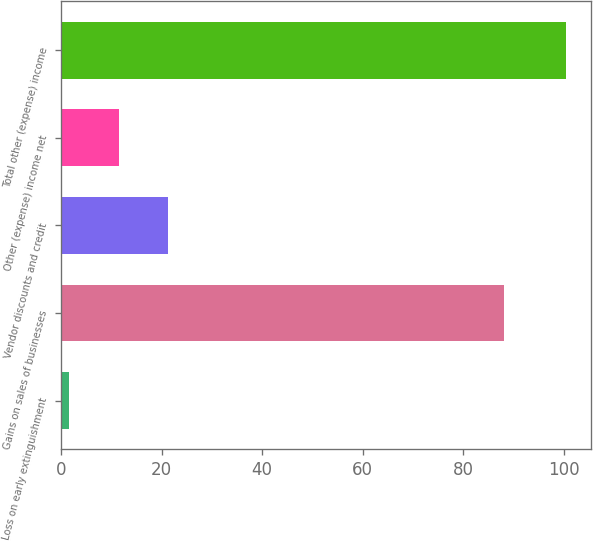Convert chart. <chart><loc_0><loc_0><loc_500><loc_500><bar_chart><fcel>Loss on early extinguishment<fcel>Gains on sales of businesses<fcel>Vendor discounts and credit<fcel>Other (expense) income net<fcel>Total other (expense) income<nl><fcel>1.53<fcel>88.2<fcel>21.33<fcel>11.43<fcel>100.5<nl></chart> 